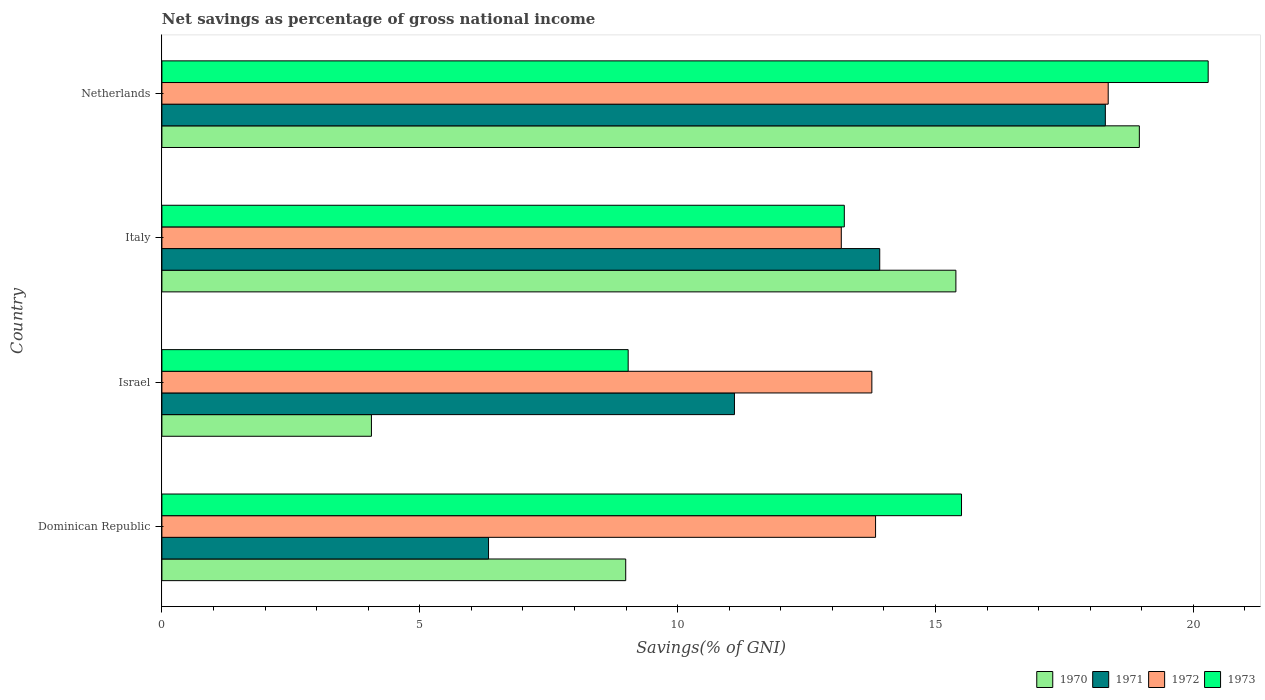How many different coloured bars are there?
Keep it short and to the point. 4. Are the number of bars per tick equal to the number of legend labels?
Provide a short and direct response. Yes. Are the number of bars on each tick of the Y-axis equal?
Offer a very short reply. Yes. What is the label of the 1st group of bars from the top?
Make the answer very short. Netherlands. What is the total savings in 1970 in Italy?
Your answer should be compact. 15.4. Across all countries, what is the maximum total savings in 1970?
Ensure brevity in your answer.  18.95. Across all countries, what is the minimum total savings in 1973?
Provide a short and direct response. 9.04. In which country was the total savings in 1972 maximum?
Your answer should be compact. Netherlands. In which country was the total savings in 1973 minimum?
Your answer should be very brief. Israel. What is the total total savings in 1970 in the graph?
Offer a terse response. 47.41. What is the difference between the total savings in 1970 in Israel and that in Netherlands?
Ensure brevity in your answer.  -14.89. What is the difference between the total savings in 1972 in Dominican Republic and the total savings in 1973 in Israel?
Keep it short and to the point. 4.8. What is the average total savings in 1973 per country?
Offer a terse response. 14.52. What is the difference between the total savings in 1971 and total savings in 1973 in Italy?
Offer a terse response. 0.69. In how many countries, is the total savings in 1973 greater than 20 %?
Offer a very short reply. 1. What is the ratio of the total savings in 1970 in Israel to that in Netherlands?
Provide a succinct answer. 0.21. What is the difference between the highest and the second highest total savings in 1972?
Give a very brief answer. 4.51. What is the difference between the highest and the lowest total savings in 1972?
Ensure brevity in your answer.  5.18. In how many countries, is the total savings in 1973 greater than the average total savings in 1973 taken over all countries?
Your answer should be very brief. 2. Is the sum of the total savings in 1972 in Dominican Republic and Italy greater than the maximum total savings in 1970 across all countries?
Give a very brief answer. Yes. What does the 3rd bar from the top in Dominican Republic represents?
Your answer should be compact. 1971. How many bars are there?
Provide a short and direct response. 16. Are all the bars in the graph horizontal?
Offer a terse response. Yes. What is the difference between two consecutive major ticks on the X-axis?
Provide a succinct answer. 5. Does the graph contain any zero values?
Your response must be concise. No. Where does the legend appear in the graph?
Your response must be concise. Bottom right. How many legend labels are there?
Your answer should be very brief. 4. What is the title of the graph?
Offer a very short reply. Net savings as percentage of gross national income. What is the label or title of the X-axis?
Make the answer very short. Savings(% of GNI). What is the Savings(% of GNI) of 1970 in Dominican Republic?
Make the answer very short. 8.99. What is the Savings(% of GNI) of 1971 in Dominican Republic?
Your answer should be compact. 6.33. What is the Savings(% of GNI) in 1972 in Dominican Republic?
Your response must be concise. 13.84. What is the Savings(% of GNI) in 1973 in Dominican Republic?
Your response must be concise. 15.5. What is the Savings(% of GNI) in 1970 in Israel?
Your response must be concise. 4.06. What is the Savings(% of GNI) of 1971 in Israel?
Your answer should be compact. 11.1. What is the Savings(% of GNI) of 1972 in Israel?
Provide a short and direct response. 13.77. What is the Savings(% of GNI) of 1973 in Israel?
Offer a terse response. 9.04. What is the Savings(% of GNI) in 1970 in Italy?
Ensure brevity in your answer.  15.4. What is the Savings(% of GNI) in 1971 in Italy?
Your answer should be compact. 13.92. What is the Savings(% of GNI) of 1972 in Italy?
Make the answer very short. 13.17. What is the Savings(% of GNI) in 1973 in Italy?
Your response must be concise. 13.23. What is the Savings(% of GNI) in 1970 in Netherlands?
Ensure brevity in your answer.  18.95. What is the Savings(% of GNI) in 1971 in Netherlands?
Make the answer very short. 18.29. What is the Savings(% of GNI) in 1972 in Netherlands?
Provide a succinct answer. 18.35. What is the Savings(% of GNI) of 1973 in Netherlands?
Your response must be concise. 20.29. Across all countries, what is the maximum Savings(% of GNI) in 1970?
Offer a very short reply. 18.95. Across all countries, what is the maximum Savings(% of GNI) of 1971?
Offer a terse response. 18.29. Across all countries, what is the maximum Savings(% of GNI) in 1972?
Your answer should be very brief. 18.35. Across all countries, what is the maximum Savings(% of GNI) of 1973?
Ensure brevity in your answer.  20.29. Across all countries, what is the minimum Savings(% of GNI) in 1970?
Offer a very short reply. 4.06. Across all countries, what is the minimum Savings(% of GNI) in 1971?
Offer a terse response. 6.33. Across all countries, what is the minimum Savings(% of GNI) in 1972?
Provide a short and direct response. 13.17. Across all countries, what is the minimum Savings(% of GNI) in 1973?
Your answer should be very brief. 9.04. What is the total Savings(% of GNI) of 1970 in the graph?
Give a very brief answer. 47.41. What is the total Savings(% of GNI) of 1971 in the graph?
Provide a short and direct response. 49.65. What is the total Savings(% of GNI) in 1972 in the graph?
Give a very brief answer. 59.13. What is the total Savings(% of GNI) of 1973 in the graph?
Provide a succinct answer. 58.07. What is the difference between the Savings(% of GNI) of 1970 in Dominican Republic and that in Israel?
Your answer should be very brief. 4.93. What is the difference between the Savings(% of GNI) in 1971 in Dominican Republic and that in Israel?
Provide a short and direct response. -4.77. What is the difference between the Savings(% of GNI) of 1972 in Dominican Republic and that in Israel?
Ensure brevity in your answer.  0.07. What is the difference between the Savings(% of GNI) in 1973 in Dominican Republic and that in Israel?
Keep it short and to the point. 6.46. What is the difference between the Savings(% of GNI) in 1970 in Dominican Republic and that in Italy?
Offer a terse response. -6.4. What is the difference between the Savings(% of GNI) in 1971 in Dominican Republic and that in Italy?
Offer a very short reply. -7.59. What is the difference between the Savings(% of GNI) of 1972 in Dominican Republic and that in Italy?
Offer a very short reply. 0.66. What is the difference between the Savings(% of GNI) of 1973 in Dominican Republic and that in Italy?
Provide a succinct answer. 2.27. What is the difference between the Savings(% of GNI) in 1970 in Dominican Republic and that in Netherlands?
Your answer should be very brief. -9.96. What is the difference between the Savings(% of GNI) of 1971 in Dominican Republic and that in Netherlands?
Make the answer very short. -11.96. What is the difference between the Savings(% of GNI) of 1972 in Dominican Republic and that in Netherlands?
Offer a very short reply. -4.51. What is the difference between the Savings(% of GNI) in 1973 in Dominican Republic and that in Netherlands?
Provide a succinct answer. -4.78. What is the difference between the Savings(% of GNI) in 1970 in Israel and that in Italy?
Provide a succinct answer. -11.33. What is the difference between the Savings(% of GNI) of 1971 in Israel and that in Italy?
Give a very brief answer. -2.82. What is the difference between the Savings(% of GNI) of 1972 in Israel and that in Italy?
Make the answer very short. 0.59. What is the difference between the Savings(% of GNI) of 1973 in Israel and that in Italy?
Keep it short and to the point. -4.19. What is the difference between the Savings(% of GNI) in 1970 in Israel and that in Netherlands?
Your answer should be very brief. -14.89. What is the difference between the Savings(% of GNI) in 1971 in Israel and that in Netherlands?
Offer a very short reply. -7.19. What is the difference between the Savings(% of GNI) in 1972 in Israel and that in Netherlands?
Offer a very short reply. -4.58. What is the difference between the Savings(% of GNI) of 1973 in Israel and that in Netherlands?
Make the answer very short. -11.25. What is the difference between the Savings(% of GNI) in 1970 in Italy and that in Netherlands?
Offer a terse response. -3.56. What is the difference between the Savings(% of GNI) of 1971 in Italy and that in Netherlands?
Provide a short and direct response. -4.37. What is the difference between the Savings(% of GNI) of 1972 in Italy and that in Netherlands?
Make the answer very short. -5.18. What is the difference between the Savings(% of GNI) of 1973 in Italy and that in Netherlands?
Your answer should be compact. -7.06. What is the difference between the Savings(% of GNI) in 1970 in Dominican Republic and the Savings(% of GNI) in 1971 in Israel?
Ensure brevity in your answer.  -2.11. What is the difference between the Savings(% of GNI) of 1970 in Dominican Republic and the Savings(% of GNI) of 1972 in Israel?
Offer a terse response. -4.77. What is the difference between the Savings(% of GNI) of 1970 in Dominican Republic and the Savings(% of GNI) of 1973 in Israel?
Offer a terse response. -0.05. What is the difference between the Savings(% of GNI) of 1971 in Dominican Republic and the Savings(% of GNI) of 1972 in Israel?
Your response must be concise. -7.43. What is the difference between the Savings(% of GNI) of 1971 in Dominican Republic and the Savings(% of GNI) of 1973 in Israel?
Offer a terse response. -2.71. What is the difference between the Savings(% of GNI) in 1972 in Dominican Republic and the Savings(% of GNI) in 1973 in Israel?
Give a very brief answer. 4.8. What is the difference between the Savings(% of GNI) of 1970 in Dominican Republic and the Savings(% of GNI) of 1971 in Italy?
Give a very brief answer. -4.93. What is the difference between the Savings(% of GNI) of 1970 in Dominican Republic and the Savings(% of GNI) of 1972 in Italy?
Make the answer very short. -4.18. What is the difference between the Savings(% of GNI) of 1970 in Dominican Republic and the Savings(% of GNI) of 1973 in Italy?
Keep it short and to the point. -4.24. What is the difference between the Savings(% of GNI) in 1971 in Dominican Republic and the Savings(% of GNI) in 1972 in Italy?
Offer a terse response. -6.84. What is the difference between the Savings(% of GNI) in 1971 in Dominican Republic and the Savings(% of GNI) in 1973 in Italy?
Make the answer very short. -6.9. What is the difference between the Savings(% of GNI) of 1972 in Dominican Republic and the Savings(% of GNI) of 1973 in Italy?
Your answer should be very brief. 0.61. What is the difference between the Savings(% of GNI) in 1970 in Dominican Republic and the Savings(% of GNI) in 1971 in Netherlands?
Provide a succinct answer. -9.3. What is the difference between the Savings(% of GNI) in 1970 in Dominican Republic and the Savings(% of GNI) in 1972 in Netherlands?
Provide a succinct answer. -9.36. What is the difference between the Savings(% of GNI) in 1970 in Dominican Republic and the Savings(% of GNI) in 1973 in Netherlands?
Your answer should be compact. -11.29. What is the difference between the Savings(% of GNI) of 1971 in Dominican Republic and the Savings(% of GNI) of 1972 in Netherlands?
Ensure brevity in your answer.  -12.02. What is the difference between the Savings(% of GNI) in 1971 in Dominican Republic and the Savings(% of GNI) in 1973 in Netherlands?
Your response must be concise. -13.95. What is the difference between the Savings(% of GNI) of 1972 in Dominican Republic and the Savings(% of GNI) of 1973 in Netherlands?
Provide a succinct answer. -6.45. What is the difference between the Savings(% of GNI) in 1970 in Israel and the Savings(% of GNI) in 1971 in Italy?
Give a very brief answer. -9.86. What is the difference between the Savings(% of GNI) in 1970 in Israel and the Savings(% of GNI) in 1972 in Italy?
Provide a short and direct response. -9.11. What is the difference between the Savings(% of GNI) of 1970 in Israel and the Savings(% of GNI) of 1973 in Italy?
Make the answer very short. -9.17. What is the difference between the Savings(% of GNI) of 1971 in Israel and the Savings(% of GNI) of 1972 in Italy?
Your answer should be compact. -2.07. What is the difference between the Savings(% of GNI) in 1971 in Israel and the Savings(% of GNI) in 1973 in Italy?
Offer a very short reply. -2.13. What is the difference between the Savings(% of GNI) of 1972 in Israel and the Savings(% of GNI) of 1973 in Italy?
Offer a very short reply. 0.53. What is the difference between the Savings(% of GNI) in 1970 in Israel and the Savings(% of GNI) in 1971 in Netherlands?
Your answer should be very brief. -14.23. What is the difference between the Savings(% of GNI) of 1970 in Israel and the Savings(% of GNI) of 1972 in Netherlands?
Provide a succinct answer. -14.29. What is the difference between the Savings(% of GNI) in 1970 in Israel and the Savings(% of GNI) in 1973 in Netherlands?
Give a very brief answer. -16.22. What is the difference between the Savings(% of GNI) of 1971 in Israel and the Savings(% of GNI) of 1972 in Netherlands?
Your answer should be very brief. -7.25. What is the difference between the Savings(% of GNI) of 1971 in Israel and the Savings(% of GNI) of 1973 in Netherlands?
Give a very brief answer. -9.19. What is the difference between the Savings(% of GNI) in 1972 in Israel and the Savings(% of GNI) in 1973 in Netherlands?
Provide a succinct answer. -6.52. What is the difference between the Savings(% of GNI) of 1970 in Italy and the Savings(% of GNI) of 1971 in Netherlands?
Ensure brevity in your answer.  -2.9. What is the difference between the Savings(% of GNI) of 1970 in Italy and the Savings(% of GNI) of 1972 in Netherlands?
Your response must be concise. -2.95. What is the difference between the Savings(% of GNI) in 1970 in Italy and the Savings(% of GNI) in 1973 in Netherlands?
Your response must be concise. -4.89. What is the difference between the Savings(% of GNI) in 1971 in Italy and the Savings(% of GNI) in 1972 in Netherlands?
Your answer should be very brief. -4.43. What is the difference between the Savings(% of GNI) in 1971 in Italy and the Savings(% of GNI) in 1973 in Netherlands?
Keep it short and to the point. -6.37. What is the difference between the Savings(% of GNI) in 1972 in Italy and the Savings(% of GNI) in 1973 in Netherlands?
Ensure brevity in your answer.  -7.11. What is the average Savings(% of GNI) in 1970 per country?
Keep it short and to the point. 11.85. What is the average Savings(% of GNI) in 1971 per country?
Provide a short and direct response. 12.41. What is the average Savings(% of GNI) in 1972 per country?
Offer a very short reply. 14.78. What is the average Savings(% of GNI) in 1973 per country?
Your response must be concise. 14.52. What is the difference between the Savings(% of GNI) of 1970 and Savings(% of GNI) of 1971 in Dominican Republic?
Offer a terse response. 2.66. What is the difference between the Savings(% of GNI) in 1970 and Savings(% of GNI) in 1972 in Dominican Republic?
Provide a succinct answer. -4.84. What is the difference between the Savings(% of GNI) in 1970 and Savings(% of GNI) in 1973 in Dominican Republic?
Your response must be concise. -6.51. What is the difference between the Savings(% of GNI) of 1971 and Savings(% of GNI) of 1972 in Dominican Republic?
Offer a very short reply. -7.5. What is the difference between the Savings(% of GNI) of 1971 and Savings(% of GNI) of 1973 in Dominican Republic?
Offer a terse response. -9.17. What is the difference between the Savings(% of GNI) in 1972 and Savings(% of GNI) in 1973 in Dominican Republic?
Make the answer very short. -1.67. What is the difference between the Savings(% of GNI) in 1970 and Savings(% of GNI) in 1971 in Israel?
Give a very brief answer. -7.04. What is the difference between the Savings(% of GNI) of 1970 and Savings(% of GNI) of 1972 in Israel?
Your answer should be very brief. -9.7. What is the difference between the Savings(% of GNI) of 1970 and Savings(% of GNI) of 1973 in Israel?
Offer a terse response. -4.98. What is the difference between the Savings(% of GNI) in 1971 and Savings(% of GNI) in 1972 in Israel?
Give a very brief answer. -2.66. What is the difference between the Savings(% of GNI) of 1971 and Savings(% of GNI) of 1973 in Israel?
Make the answer very short. 2.06. What is the difference between the Savings(% of GNI) of 1972 and Savings(% of GNI) of 1973 in Israel?
Your answer should be very brief. 4.73. What is the difference between the Savings(% of GNI) of 1970 and Savings(% of GNI) of 1971 in Italy?
Offer a terse response. 1.48. What is the difference between the Savings(% of GNI) of 1970 and Savings(% of GNI) of 1972 in Italy?
Offer a very short reply. 2.22. What is the difference between the Savings(% of GNI) in 1970 and Savings(% of GNI) in 1973 in Italy?
Give a very brief answer. 2.16. What is the difference between the Savings(% of GNI) of 1971 and Savings(% of GNI) of 1972 in Italy?
Make the answer very short. 0.75. What is the difference between the Savings(% of GNI) in 1971 and Savings(% of GNI) in 1973 in Italy?
Ensure brevity in your answer.  0.69. What is the difference between the Savings(% of GNI) in 1972 and Savings(% of GNI) in 1973 in Italy?
Ensure brevity in your answer.  -0.06. What is the difference between the Savings(% of GNI) of 1970 and Savings(% of GNI) of 1971 in Netherlands?
Give a very brief answer. 0.66. What is the difference between the Savings(% of GNI) in 1970 and Savings(% of GNI) in 1972 in Netherlands?
Ensure brevity in your answer.  0.6. What is the difference between the Savings(% of GNI) of 1970 and Savings(% of GNI) of 1973 in Netherlands?
Ensure brevity in your answer.  -1.33. What is the difference between the Savings(% of GNI) in 1971 and Savings(% of GNI) in 1972 in Netherlands?
Ensure brevity in your answer.  -0.06. What is the difference between the Savings(% of GNI) of 1971 and Savings(% of GNI) of 1973 in Netherlands?
Your answer should be very brief. -1.99. What is the difference between the Savings(% of GNI) of 1972 and Savings(% of GNI) of 1973 in Netherlands?
Your answer should be very brief. -1.94. What is the ratio of the Savings(% of GNI) in 1970 in Dominican Republic to that in Israel?
Provide a short and direct response. 2.21. What is the ratio of the Savings(% of GNI) of 1971 in Dominican Republic to that in Israel?
Ensure brevity in your answer.  0.57. What is the ratio of the Savings(% of GNI) in 1973 in Dominican Republic to that in Israel?
Your response must be concise. 1.71. What is the ratio of the Savings(% of GNI) of 1970 in Dominican Republic to that in Italy?
Ensure brevity in your answer.  0.58. What is the ratio of the Savings(% of GNI) in 1971 in Dominican Republic to that in Italy?
Provide a succinct answer. 0.46. What is the ratio of the Savings(% of GNI) in 1972 in Dominican Republic to that in Italy?
Ensure brevity in your answer.  1.05. What is the ratio of the Savings(% of GNI) of 1973 in Dominican Republic to that in Italy?
Provide a succinct answer. 1.17. What is the ratio of the Savings(% of GNI) of 1970 in Dominican Republic to that in Netherlands?
Provide a short and direct response. 0.47. What is the ratio of the Savings(% of GNI) of 1971 in Dominican Republic to that in Netherlands?
Your answer should be compact. 0.35. What is the ratio of the Savings(% of GNI) in 1972 in Dominican Republic to that in Netherlands?
Your answer should be very brief. 0.75. What is the ratio of the Savings(% of GNI) in 1973 in Dominican Republic to that in Netherlands?
Your response must be concise. 0.76. What is the ratio of the Savings(% of GNI) of 1970 in Israel to that in Italy?
Keep it short and to the point. 0.26. What is the ratio of the Savings(% of GNI) in 1971 in Israel to that in Italy?
Give a very brief answer. 0.8. What is the ratio of the Savings(% of GNI) in 1972 in Israel to that in Italy?
Give a very brief answer. 1.04. What is the ratio of the Savings(% of GNI) of 1973 in Israel to that in Italy?
Give a very brief answer. 0.68. What is the ratio of the Savings(% of GNI) in 1970 in Israel to that in Netherlands?
Keep it short and to the point. 0.21. What is the ratio of the Savings(% of GNI) of 1971 in Israel to that in Netherlands?
Your answer should be compact. 0.61. What is the ratio of the Savings(% of GNI) of 1972 in Israel to that in Netherlands?
Make the answer very short. 0.75. What is the ratio of the Savings(% of GNI) of 1973 in Israel to that in Netherlands?
Your answer should be very brief. 0.45. What is the ratio of the Savings(% of GNI) in 1970 in Italy to that in Netherlands?
Your answer should be very brief. 0.81. What is the ratio of the Savings(% of GNI) of 1971 in Italy to that in Netherlands?
Your answer should be compact. 0.76. What is the ratio of the Savings(% of GNI) of 1972 in Italy to that in Netherlands?
Ensure brevity in your answer.  0.72. What is the ratio of the Savings(% of GNI) in 1973 in Italy to that in Netherlands?
Ensure brevity in your answer.  0.65. What is the difference between the highest and the second highest Savings(% of GNI) of 1970?
Keep it short and to the point. 3.56. What is the difference between the highest and the second highest Savings(% of GNI) in 1971?
Your response must be concise. 4.37. What is the difference between the highest and the second highest Savings(% of GNI) of 1972?
Keep it short and to the point. 4.51. What is the difference between the highest and the second highest Savings(% of GNI) in 1973?
Your response must be concise. 4.78. What is the difference between the highest and the lowest Savings(% of GNI) in 1970?
Provide a short and direct response. 14.89. What is the difference between the highest and the lowest Savings(% of GNI) in 1971?
Your answer should be compact. 11.96. What is the difference between the highest and the lowest Savings(% of GNI) in 1972?
Your answer should be compact. 5.18. What is the difference between the highest and the lowest Savings(% of GNI) in 1973?
Offer a very short reply. 11.25. 